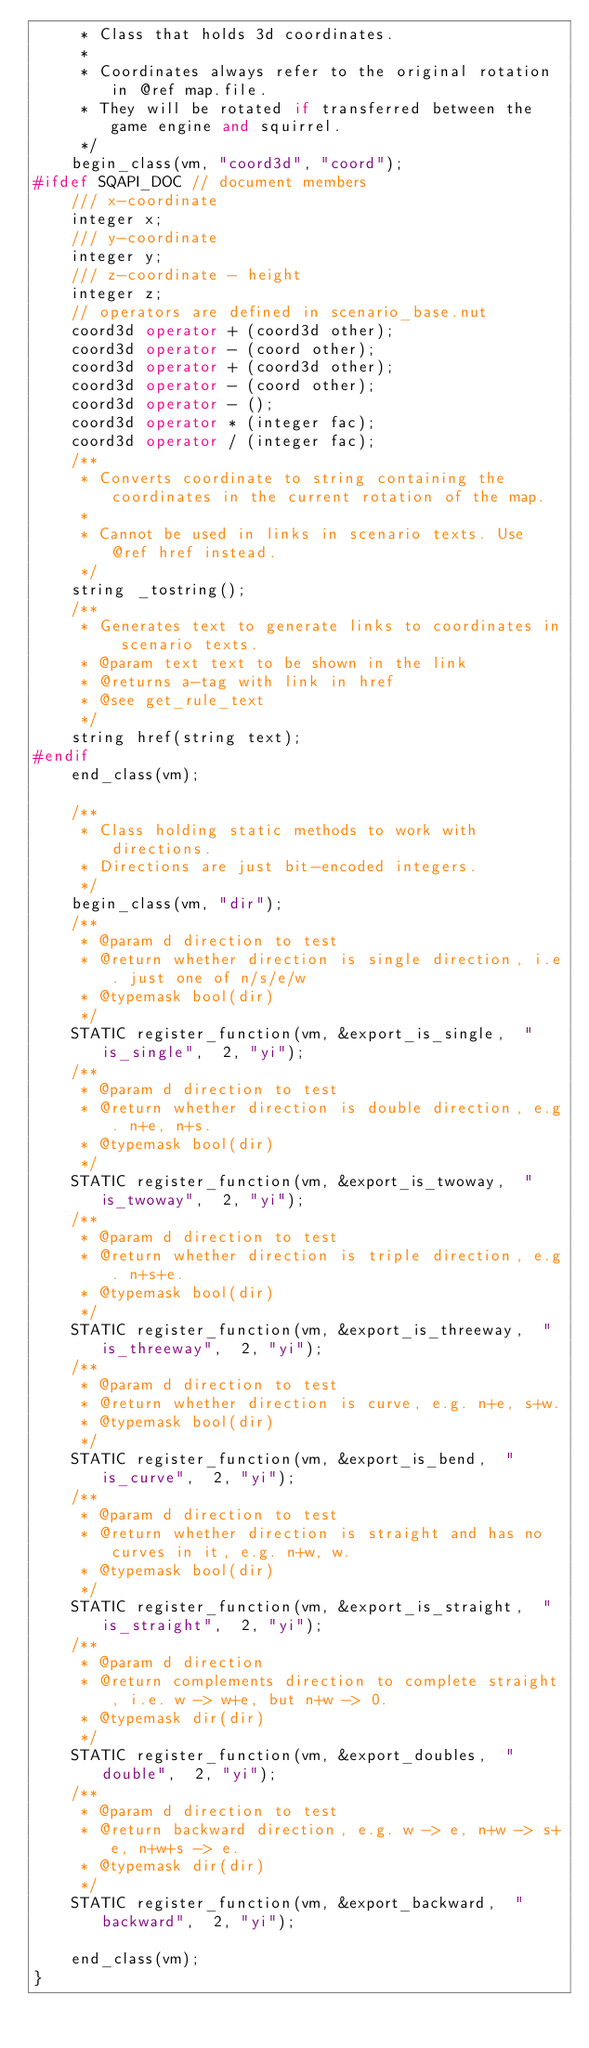Convert code to text. <code><loc_0><loc_0><loc_500><loc_500><_C++_>	 * Class that holds 3d coordinates.
	 *
	 * Coordinates always refer to the original rotation in @ref map.file.
	 * They will be rotated if transferred between the game engine and squirrel.
	 */
	begin_class(vm, "coord3d", "coord");
#ifdef SQAPI_DOC // document members
	/// x-coordinate
	integer x;
	/// y-coordinate
	integer y;
	/// z-coordinate - height
	integer z;
	// operators are defined in scenario_base.nut
	coord3d operator + (coord3d other);
	coord3d operator - (coord other);
	coord3d operator + (coord3d other);
	coord3d operator - (coord other);
	coord3d operator - ();
	coord3d operator * (integer fac);
	coord3d operator / (integer fac);
	/**
	 * Converts coordinate to string containing the coordinates in the current rotation of the map.
	 *
	 * Cannot be used in links in scenario texts. Use @ref href instead.
	 */
	string _tostring();
	/**
	 * Generates text to generate links to coordinates in scenario texts.
	 * @param text text to be shown in the link
	 * @returns a-tag with link in href
	 * @see get_rule_text
	 */
	string href(string text);
#endif
	end_class(vm);

	/**
	 * Class holding static methods to work with directions.
	 * Directions are just bit-encoded integers.
	 */
	begin_class(vm, "dir");
	/**
	 * @param d direction to test
	 * @return whether direction is single direction, i.e. just one of n/s/e/w
	 * @typemask bool(dir)
	 */
	STATIC register_function(vm, &export_is_single,  "is_single",  2, "yi");
	/**
	 * @param d direction to test
	 * @return whether direction is double direction, e.g. n+e, n+s.
	 * @typemask bool(dir)
	 */
	STATIC register_function(vm, &export_is_twoway,  "is_twoway",  2, "yi");
	/**
	 * @param d direction to test
	 * @return whether direction is triple direction, e.g. n+s+e.
	 * @typemask bool(dir)
	 */
	STATIC register_function(vm, &export_is_threeway,  "is_threeway",  2, "yi");
	/**
	 * @param d direction to test
	 * @return whether direction is curve, e.g. n+e, s+w.
	 * @typemask bool(dir)
	 */
	STATIC register_function(vm, &export_is_bend,  "is_curve",  2, "yi");
	/**
	 * @param d direction to test
	 * @return whether direction is straight and has no curves in it, e.g. n+w, w.
	 * @typemask bool(dir)
	 */
	STATIC register_function(vm, &export_is_straight,  "is_straight",  2, "yi");
	/**
	 * @param d direction
	 * @return complements direction to complete straight, i.e. w -> w+e, but n+w -> 0.
	 * @typemask dir(dir)
	 */
	STATIC register_function(vm, &export_doubles,  "double",  2, "yi");
	/**
	 * @param d direction to test
	 * @return backward direction, e.g. w -> e, n+w -> s+e, n+w+s -> e.
	 * @typemask dir(dir)
	 */
	STATIC register_function(vm, &export_backward,  "backward",  2, "yi");

	end_class(vm);
}
</code> 